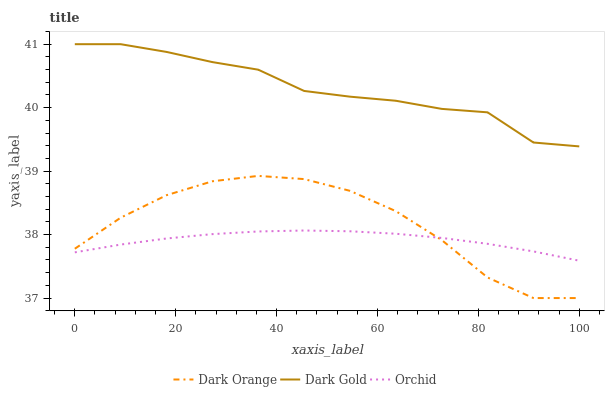Does Orchid have the minimum area under the curve?
Answer yes or no. Yes. Does Dark Gold have the maximum area under the curve?
Answer yes or no. Yes. Does Dark Gold have the minimum area under the curve?
Answer yes or no. No. Does Orchid have the maximum area under the curve?
Answer yes or no. No. Is Orchid the smoothest?
Answer yes or no. Yes. Is Dark Orange the roughest?
Answer yes or no. Yes. Is Dark Gold the smoothest?
Answer yes or no. No. Is Dark Gold the roughest?
Answer yes or no. No. Does Orchid have the lowest value?
Answer yes or no. No. Does Dark Gold have the highest value?
Answer yes or no. Yes. Does Orchid have the highest value?
Answer yes or no. No. Is Dark Orange less than Dark Gold?
Answer yes or no. Yes. Is Dark Gold greater than Orchid?
Answer yes or no. Yes. Does Orchid intersect Dark Orange?
Answer yes or no. Yes. Is Orchid less than Dark Orange?
Answer yes or no. No. Is Orchid greater than Dark Orange?
Answer yes or no. No. Does Dark Orange intersect Dark Gold?
Answer yes or no. No. 